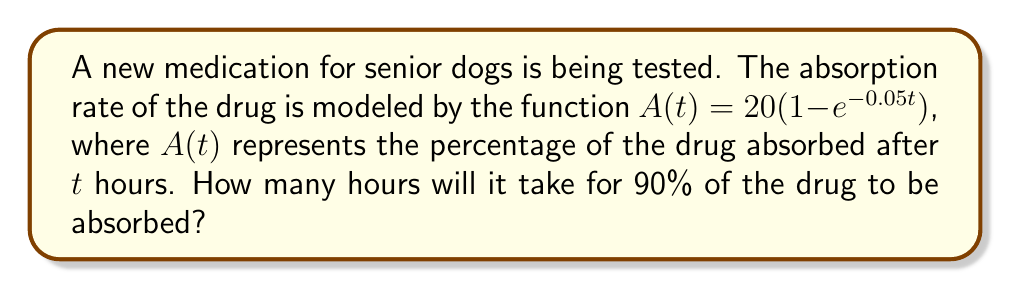Solve this math problem. To solve this problem, we need to follow these steps:

1) We want to find $t$ when $A(t) = 90$. So, we set up the equation:
   
   $90 = 20(1 - e^{-0.05t})$

2) Divide both sides by 20:
   
   $\frac{90}{20} = 1 - e^{-0.05t}$
   
   $4.5 = 1 - e^{-0.05t}$

3) Subtract both sides from 1:
   
   $-3.5 = -e^{-0.05t}$

4) Multiply both sides by -1:
   
   $3.5 = e^{-0.05t}$

5) Take the natural log of both sides:
   
   $\ln(3.5) = \ln(e^{-0.05t})$
   
   $\ln(3.5) = -0.05t$

6) Divide both sides by -0.05:
   
   $\frac{\ln(3.5)}{-0.05} = t$

7) Calculate the result:
   
   $t \approx 25.14$ hours

Therefore, it will take approximately 25.14 hours for 90% of the drug to be absorbed in senior dogs.
Answer: 25.14 hours 